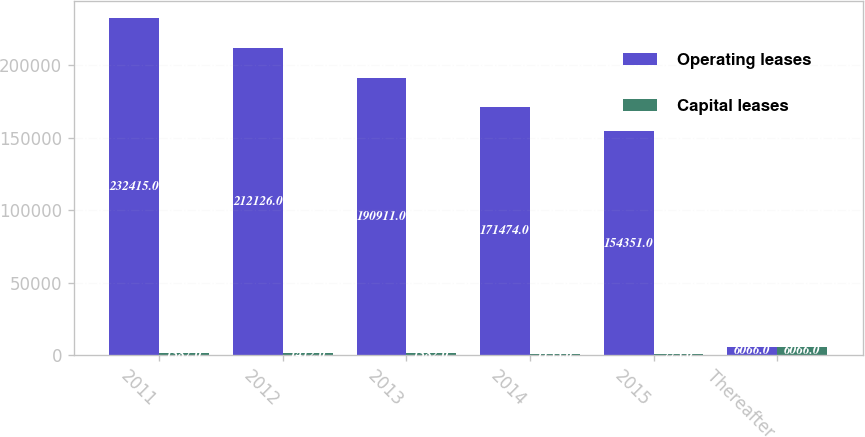<chart> <loc_0><loc_0><loc_500><loc_500><stacked_bar_chart><ecel><fcel>2011<fcel>2012<fcel>2013<fcel>2014<fcel>2015<fcel>Thereafter<nl><fcel>Operating leases<fcel>232415<fcel>212126<fcel>190911<fcel>171474<fcel>154351<fcel>6066<nl><fcel>Capital leases<fcel>1387<fcel>1412<fcel>1382<fcel>1133<fcel>773<fcel>6066<nl></chart> 